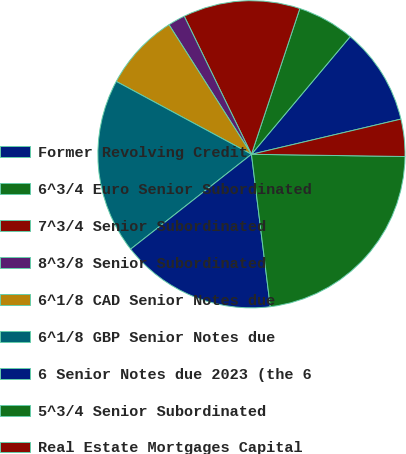<chart> <loc_0><loc_0><loc_500><loc_500><pie_chart><fcel>Former Revolving Credit<fcel>6^3/4 Euro Senior Subordinated<fcel>7^3/4 Senior Subordinated<fcel>8^3/8 Senior Subordinated<fcel>6^1/8 CAD Senior Notes due<fcel>6^1/8 GBP Senior Notes due<fcel>6 Senior Notes due 2023 (the 6<fcel>5^3/4 Senior Subordinated<fcel>Real Estate Mortgages Capital<nl><fcel>10.21%<fcel>6.01%<fcel>12.31%<fcel>1.81%<fcel>8.11%<fcel>18.46%<fcel>16.36%<fcel>22.81%<fcel>3.91%<nl></chart> 